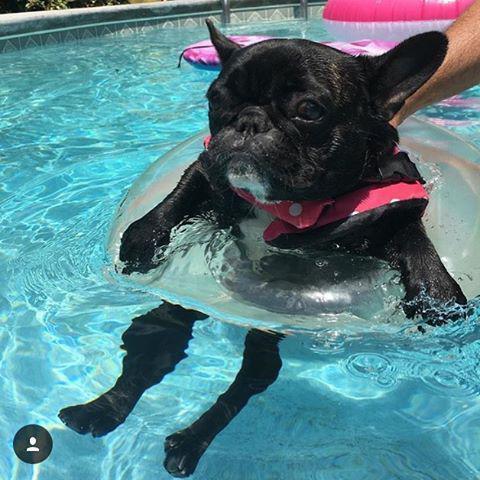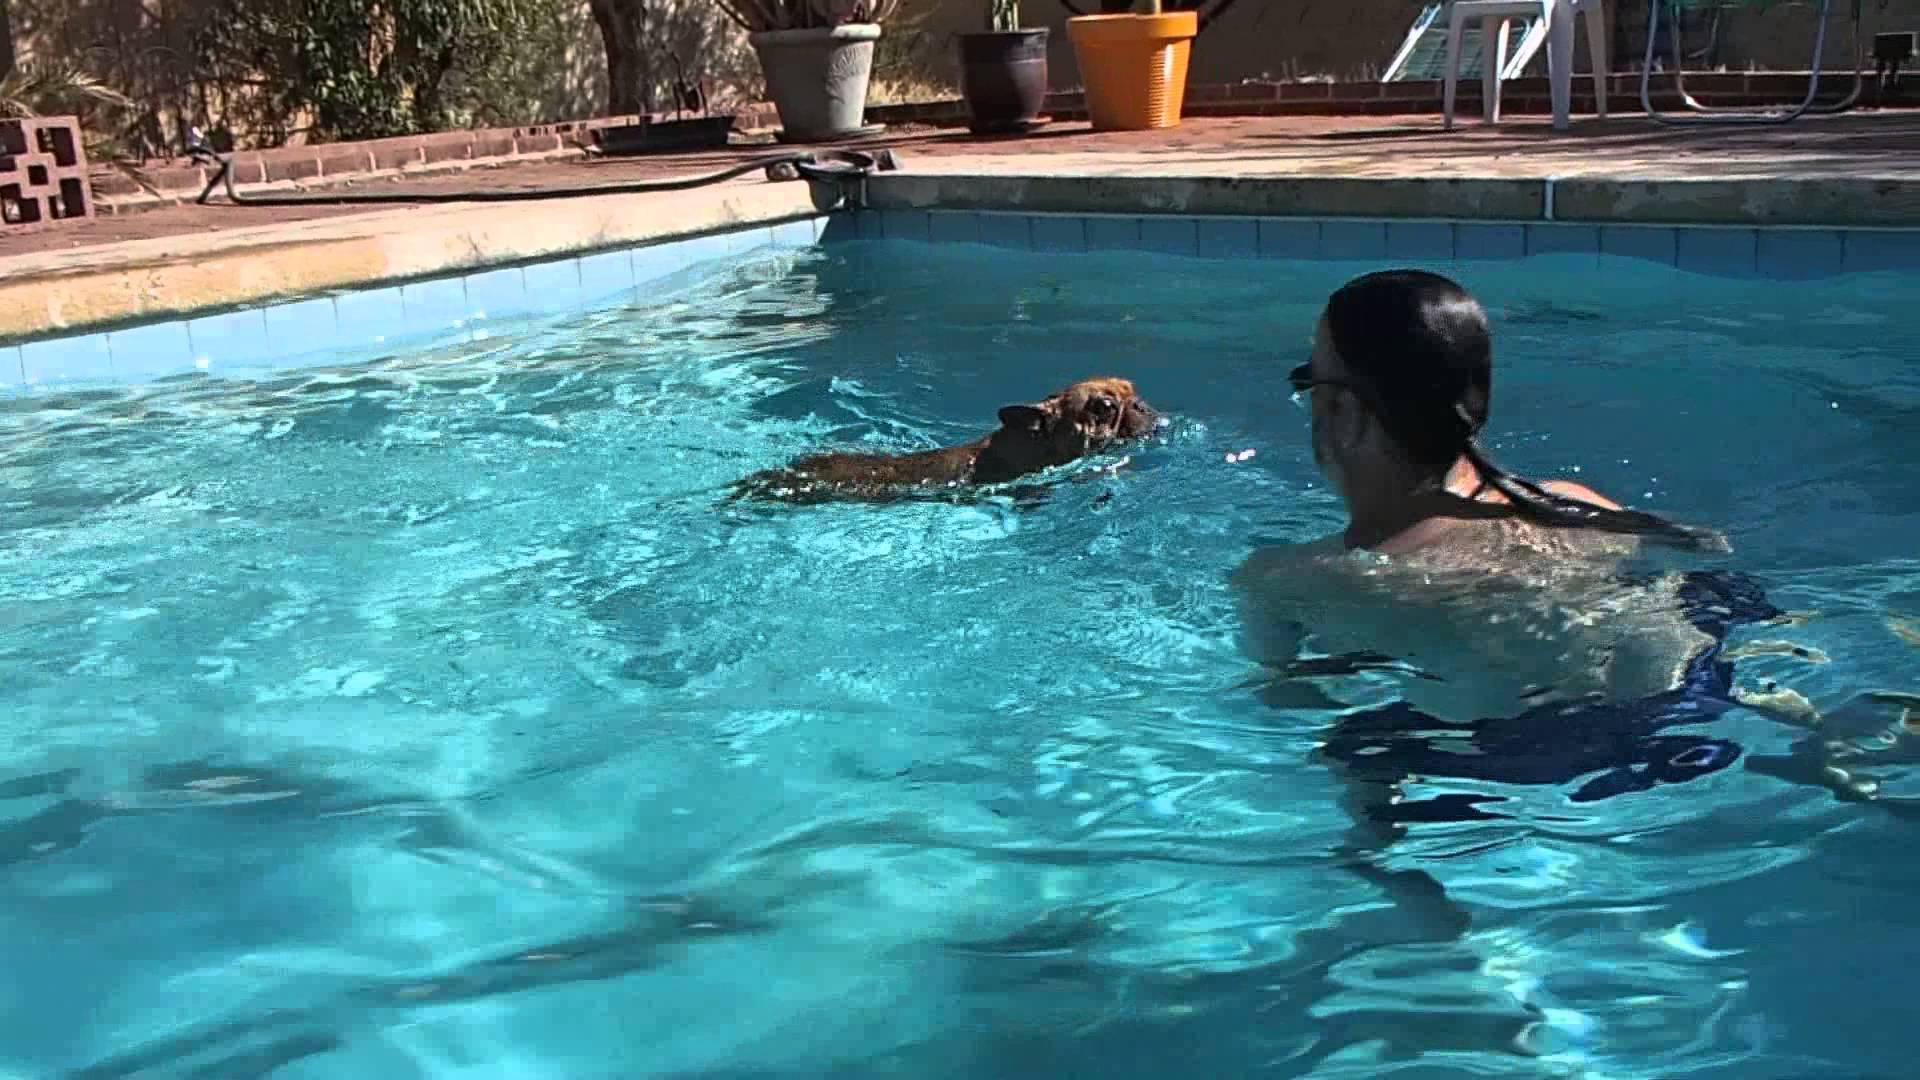The first image is the image on the left, the second image is the image on the right. Assess this claim about the two images: "There is a black dog floating in an inner tube in a swimming pool". Correct or not? Answer yes or no. Yes. The first image is the image on the left, the second image is the image on the right. Assess this claim about the two images: "there are dogs floating in the pool on inflatable intertubes". Correct or not? Answer yes or no. Yes. 